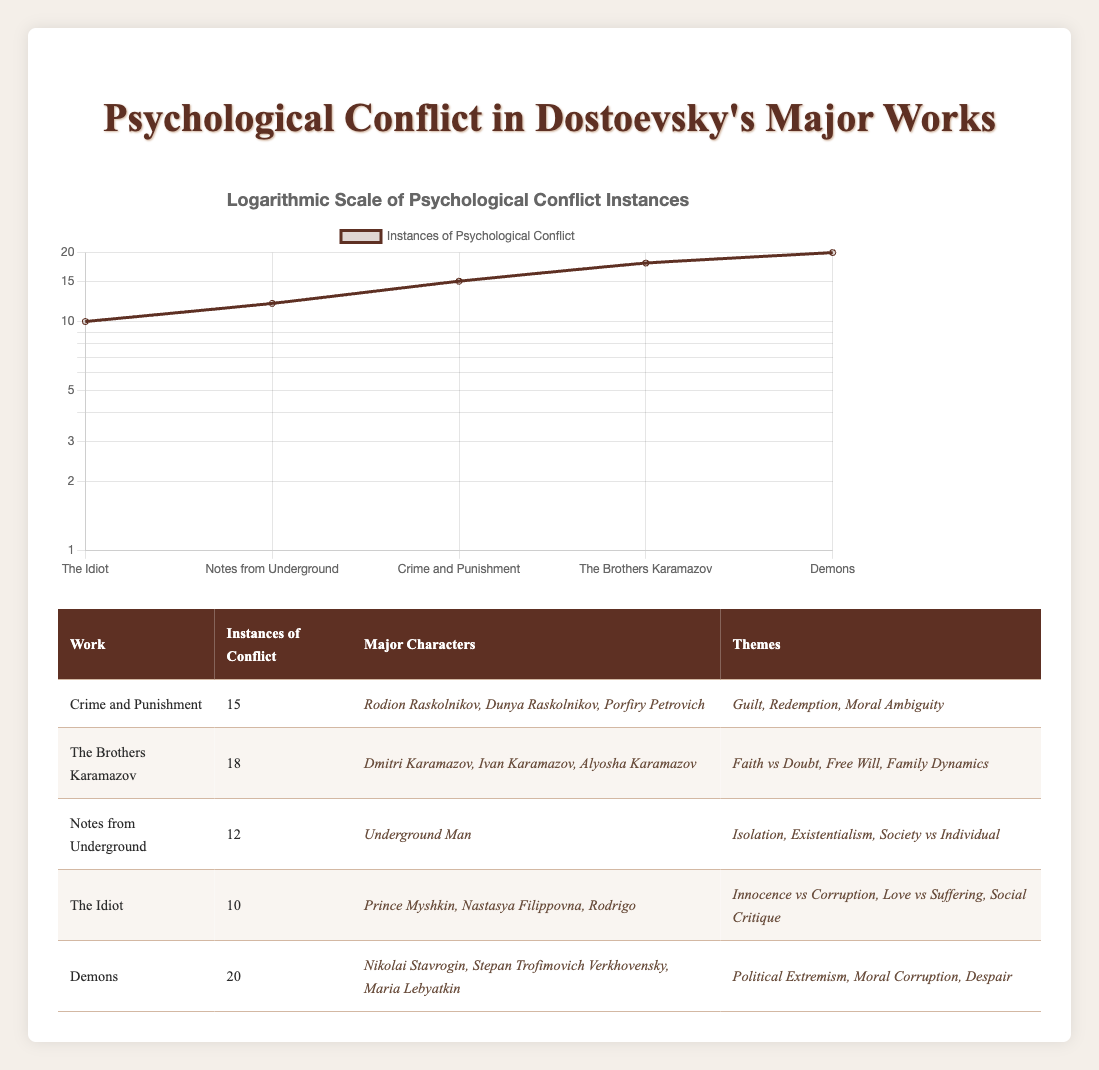What is the maximum number of instances of conflict found in a single work? The table shows that "Demons" has the highest count of psychological conflict instances, with 20.
Answer: 20 Which novel has fewer instances of conflict: "Crime and Punishment" or "The Idiot"? "Crime and Punishment" has 15 instances while "The Idiot" has 10 instances. Therefore, "The Idiot" has fewer instances.
Answer: The Idiot What is the total number of instances of conflict across all five works? By adding the instances from each work: 15 + 18 + 12 + 10 + 20 = 75.
Answer: 75 Is "The Brothers Karamazov" one of the top two works with the highest instances of conflict? "The Brothers Karamazov" has 18 instances, making it one of the top two as "Demons" (20) has the highest and "The Brothers Karamazov" has the second highest.
Answer: Yes What themes are present in both "Crime and Punishment" and "Demons"? "Crime and Punishment" contains themes of guilt and redemption, while "Demons" highlights moral corruption and despair. The key theme common to both works is moral ambiguity as both explore complex ethical dilemmas.
Answer: No 